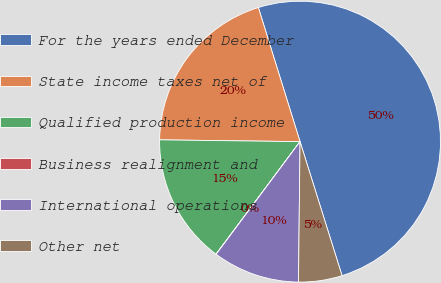<chart> <loc_0><loc_0><loc_500><loc_500><pie_chart><fcel>For the years ended December<fcel>State income taxes net of<fcel>Qualified production income<fcel>Business realignment and<fcel>International operations<fcel>Other net<nl><fcel>49.97%<fcel>20.0%<fcel>15.0%<fcel>0.02%<fcel>10.01%<fcel>5.01%<nl></chart> 